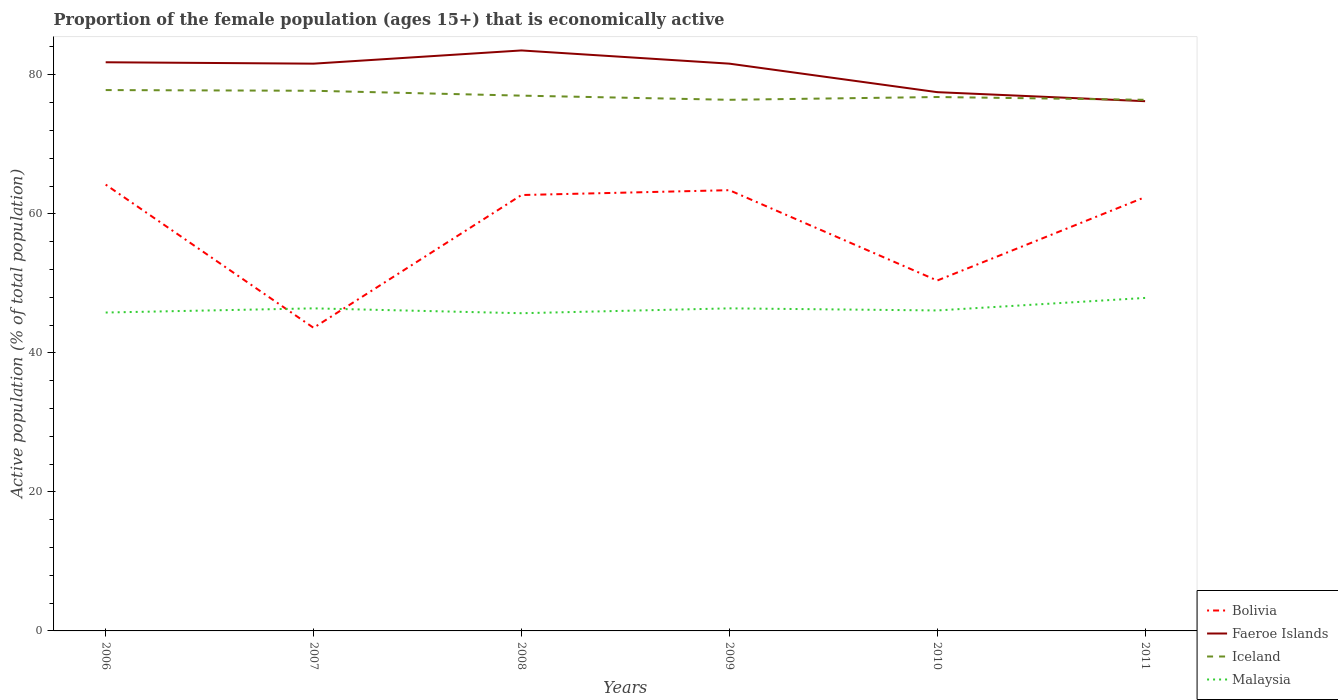How many different coloured lines are there?
Offer a very short reply. 4. Is the number of lines equal to the number of legend labels?
Offer a terse response. Yes. Across all years, what is the maximum proportion of the female population that is economically active in Iceland?
Offer a terse response. 76.4. What is the difference between the highest and the second highest proportion of the female population that is economically active in Faeroe Islands?
Provide a succinct answer. 7.3. What is the difference between the highest and the lowest proportion of the female population that is economically active in Bolivia?
Keep it short and to the point. 4. Is the proportion of the female population that is economically active in Faeroe Islands strictly greater than the proportion of the female population that is economically active in Bolivia over the years?
Your answer should be compact. No. How many lines are there?
Provide a succinct answer. 4. Where does the legend appear in the graph?
Offer a very short reply. Bottom right. How many legend labels are there?
Make the answer very short. 4. How are the legend labels stacked?
Your answer should be compact. Vertical. What is the title of the graph?
Give a very brief answer. Proportion of the female population (ages 15+) that is economically active. What is the label or title of the X-axis?
Offer a terse response. Years. What is the label or title of the Y-axis?
Offer a very short reply. Active population (% of total population). What is the Active population (% of total population) of Bolivia in 2006?
Offer a terse response. 64.2. What is the Active population (% of total population) in Faeroe Islands in 2006?
Your response must be concise. 81.8. What is the Active population (% of total population) of Iceland in 2006?
Provide a succinct answer. 77.8. What is the Active population (% of total population) in Malaysia in 2006?
Ensure brevity in your answer.  45.8. What is the Active population (% of total population) in Bolivia in 2007?
Ensure brevity in your answer.  43.6. What is the Active population (% of total population) of Faeroe Islands in 2007?
Offer a terse response. 81.6. What is the Active population (% of total population) in Iceland in 2007?
Your answer should be very brief. 77.7. What is the Active population (% of total population) of Malaysia in 2007?
Ensure brevity in your answer.  46.4. What is the Active population (% of total population) in Bolivia in 2008?
Provide a succinct answer. 62.7. What is the Active population (% of total population) in Faeroe Islands in 2008?
Make the answer very short. 83.5. What is the Active population (% of total population) in Iceland in 2008?
Ensure brevity in your answer.  77. What is the Active population (% of total population) in Malaysia in 2008?
Provide a short and direct response. 45.7. What is the Active population (% of total population) in Bolivia in 2009?
Your answer should be compact. 63.4. What is the Active population (% of total population) in Faeroe Islands in 2009?
Offer a very short reply. 81.6. What is the Active population (% of total population) in Iceland in 2009?
Your response must be concise. 76.4. What is the Active population (% of total population) in Malaysia in 2009?
Your answer should be very brief. 46.4. What is the Active population (% of total population) in Bolivia in 2010?
Offer a very short reply. 50.4. What is the Active population (% of total population) in Faeroe Islands in 2010?
Your answer should be very brief. 77.5. What is the Active population (% of total population) of Iceland in 2010?
Your answer should be very brief. 76.8. What is the Active population (% of total population) of Malaysia in 2010?
Your answer should be very brief. 46.1. What is the Active population (% of total population) in Bolivia in 2011?
Provide a short and direct response. 62.4. What is the Active population (% of total population) in Faeroe Islands in 2011?
Keep it short and to the point. 76.2. What is the Active population (% of total population) in Iceland in 2011?
Keep it short and to the point. 76.4. What is the Active population (% of total population) in Malaysia in 2011?
Provide a short and direct response. 47.9. Across all years, what is the maximum Active population (% of total population) in Bolivia?
Offer a very short reply. 64.2. Across all years, what is the maximum Active population (% of total population) of Faeroe Islands?
Offer a very short reply. 83.5. Across all years, what is the maximum Active population (% of total population) in Iceland?
Your answer should be very brief. 77.8. Across all years, what is the maximum Active population (% of total population) in Malaysia?
Offer a terse response. 47.9. Across all years, what is the minimum Active population (% of total population) in Bolivia?
Make the answer very short. 43.6. Across all years, what is the minimum Active population (% of total population) in Faeroe Islands?
Ensure brevity in your answer.  76.2. Across all years, what is the minimum Active population (% of total population) in Iceland?
Offer a very short reply. 76.4. Across all years, what is the minimum Active population (% of total population) in Malaysia?
Provide a succinct answer. 45.7. What is the total Active population (% of total population) in Bolivia in the graph?
Provide a succinct answer. 346.7. What is the total Active population (% of total population) in Faeroe Islands in the graph?
Your answer should be compact. 482.2. What is the total Active population (% of total population) of Iceland in the graph?
Offer a terse response. 462.1. What is the total Active population (% of total population) of Malaysia in the graph?
Your response must be concise. 278.3. What is the difference between the Active population (% of total population) of Bolivia in 2006 and that in 2007?
Offer a very short reply. 20.6. What is the difference between the Active population (% of total population) of Iceland in 2006 and that in 2007?
Offer a very short reply. 0.1. What is the difference between the Active population (% of total population) of Iceland in 2006 and that in 2008?
Offer a terse response. 0.8. What is the difference between the Active population (% of total population) in Malaysia in 2006 and that in 2008?
Your response must be concise. 0.1. What is the difference between the Active population (% of total population) of Faeroe Islands in 2006 and that in 2009?
Offer a very short reply. 0.2. What is the difference between the Active population (% of total population) in Iceland in 2006 and that in 2009?
Your response must be concise. 1.4. What is the difference between the Active population (% of total population) in Bolivia in 2006 and that in 2010?
Provide a succinct answer. 13.8. What is the difference between the Active population (% of total population) of Faeroe Islands in 2006 and that in 2010?
Make the answer very short. 4.3. What is the difference between the Active population (% of total population) in Bolivia in 2006 and that in 2011?
Your answer should be compact. 1.8. What is the difference between the Active population (% of total population) of Bolivia in 2007 and that in 2008?
Your answer should be compact. -19.1. What is the difference between the Active population (% of total population) in Malaysia in 2007 and that in 2008?
Give a very brief answer. 0.7. What is the difference between the Active population (% of total population) of Bolivia in 2007 and that in 2009?
Offer a terse response. -19.8. What is the difference between the Active population (% of total population) of Bolivia in 2007 and that in 2010?
Make the answer very short. -6.8. What is the difference between the Active population (% of total population) of Iceland in 2007 and that in 2010?
Your answer should be very brief. 0.9. What is the difference between the Active population (% of total population) of Bolivia in 2007 and that in 2011?
Your answer should be compact. -18.8. What is the difference between the Active population (% of total population) in Iceland in 2007 and that in 2011?
Offer a terse response. 1.3. What is the difference between the Active population (% of total population) in Malaysia in 2007 and that in 2011?
Offer a very short reply. -1.5. What is the difference between the Active population (% of total population) of Bolivia in 2008 and that in 2009?
Provide a succinct answer. -0.7. What is the difference between the Active population (% of total population) in Iceland in 2008 and that in 2009?
Offer a very short reply. 0.6. What is the difference between the Active population (% of total population) in Malaysia in 2008 and that in 2009?
Keep it short and to the point. -0.7. What is the difference between the Active population (% of total population) in Malaysia in 2008 and that in 2010?
Offer a very short reply. -0.4. What is the difference between the Active population (% of total population) of Bolivia in 2008 and that in 2011?
Provide a succinct answer. 0.3. What is the difference between the Active population (% of total population) of Faeroe Islands in 2008 and that in 2011?
Offer a terse response. 7.3. What is the difference between the Active population (% of total population) in Malaysia in 2008 and that in 2011?
Provide a short and direct response. -2.2. What is the difference between the Active population (% of total population) of Bolivia in 2009 and that in 2010?
Offer a very short reply. 13. What is the difference between the Active population (% of total population) of Faeroe Islands in 2009 and that in 2010?
Provide a short and direct response. 4.1. What is the difference between the Active population (% of total population) in Iceland in 2009 and that in 2010?
Ensure brevity in your answer.  -0.4. What is the difference between the Active population (% of total population) of Malaysia in 2009 and that in 2010?
Ensure brevity in your answer.  0.3. What is the difference between the Active population (% of total population) in Bolivia in 2009 and that in 2011?
Provide a succinct answer. 1. What is the difference between the Active population (% of total population) in Faeroe Islands in 2009 and that in 2011?
Your answer should be very brief. 5.4. What is the difference between the Active population (% of total population) in Iceland in 2009 and that in 2011?
Give a very brief answer. 0. What is the difference between the Active population (% of total population) of Malaysia in 2009 and that in 2011?
Provide a short and direct response. -1.5. What is the difference between the Active population (% of total population) of Bolivia in 2010 and that in 2011?
Your answer should be very brief. -12. What is the difference between the Active population (% of total population) in Bolivia in 2006 and the Active population (% of total population) in Faeroe Islands in 2007?
Your answer should be very brief. -17.4. What is the difference between the Active population (% of total population) of Bolivia in 2006 and the Active population (% of total population) of Malaysia in 2007?
Give a very brief answer. 17.8. What is the difference between the Active population (% of total population) of Faeroe Islands in 2006 and the Active population (% of total population) of Malaysia in 2007?
Make the answer very short. 35.4. What is the difference between the Active population (% of total population) in Iceland in 2006 and the Active population (% of total population) in Malaysia in 2007?
Your answer should be compact. 31.4. What is the difference between the Active population (% of total population) in Bolivia in 2006 and the Active population (% of total population) in Faeroe Islands in 2008?
Ensure brevity in your answer.  -19.3. What is the difference between the Active population (% of total population) in Bolivia in 2006 and the Active population (% of total population) in Iceland in 2008?
Offer a terse response. -12.8. What is the difference between the Active population (% of total population) in Faeroe Islands in 2006 and the Active population (% of total population) in Malaysia in 2008?
Offer a very short reply. 36.1. What is the difference between the Active population (% of total population) of Iceland in 2006 and the Active population (% of total population) of Malaysia in 2008?
Ensure brevity in your answer.  32.1. What is the difference between the Active population (% of total population) of Bolivia in 2006 and the Active population (% of total population) of Faeroe Islands in 2009?
Provide a short and direct response. -17.4. What is the difference between the Active population (% of total population) of Bolivia in 2006 and the Active population (% of total population) of Malaysia in 2009?
Your answer should be very brief. 17.8. What is the difference between the Active population (% of total population) in Faeroe Islands in 2006 and the Active population (% of total population) in Iceland in 2009?
Provide a succinct answer. 5.4. What is the difference between the Active population (% of total population) in Faeroe Islands in 2006 and the Active population (% of total population) in Malaysia in 2009?
Give a very brief answer. 35.4. What is the difference between the Active population (% of total population) in Iceland in 2006 and the Active population (% of total population) in Malaysia in 2009?
Provide a succinct answer. 31.4. What is the difference between the Active population (% of total population) in Bolivia in 2006 and the Active population (% of total population) in Malaysia in 2010?
Provide a succinct answer. 18.1. What is the difference between the Active population (% of total population) in Faeroe Islands in 2006 and the Active population (% of total population) in Iceland in 2010?
Your response must be concise. 5. What is the difference between the Active population (% of total population) in Faeroe Islands in 2006 and the Active population (% of total population) in Malaysia in 2010?
Your answer should be very brief. 35.7. What is the difference between the Active population (% of total population) of Iceland in 2006 and the Active population (% of total population) of Malaysia in 2010?
Give a very brief answer. 31.7. What is the difference between the Active population (% of total population) of Bolivia in 2006 and the Active population (% of total population) of Faeroe Islands in 2011?
Your answer should be compact. -12. What is the difference between the Active population (% of total population) of Bolivia in 2006 and the Active population (% of total population) of Iceland in 2011?
Offer a terse response. -12.2. What is the difference between the Active population (% of total population) of Faeroe Islands in 2006 and the Active population (% of total population) of Malaysia in 2011?
Provide a succinct answer. 33.9. What is the difference between the Active population (% of total population) of Iceland in 2006 and the Active population (% of total population) of Malaysia in 2011?
Provide a succinct answer. 29.9. What is the difference between the Active population (% of total population) of Bolivia in 2007 and the Active population (% of total population) of Faeroe Islands in 2008?
Offer a terse response. -39.9. What is the difference between the Active population (% of total population) of Bolivia in 2007 and the Active population (% of total population) of Iceland in 2008?
Your answer should be very brief. -33.4. What is the difference between the Active population (% of total population) of Bolivia in 2007 and the Active population (% of total population) of Malaysia in 2008?
Your answer should be very brief. -2.1. What is the difference between the Active population (% of total population) of Faeroe Islands in 2007 and the Active population (% of total population) of Iceland in 2008?
Provide a short and direct response. 4.6. What is the difference between the Active population (% of total population) in Faeroe Islands in 2007 and the Active population (% of total population) in Malaysia in 2008?
Keep it short and to the point. 35.9. What is the difference between the Active population (% of total population) in Bolivia in 2007 and the Active population (% of total population) in Faeroe Islands in 2009?
Provide a short and direct response. -38. What is the difference between the Active population (% of total population) of Bolivia in 2007 and the Active population (% of total population) of Iceland in 2009?
Make the answer very short. -32.8. What is the difference between the Active population (% of total population) of Faeroe Islands in 2007 and the Active population (% of total population) of Malaysia in 2009?
Give a very brief answer. 35.2. What is the difference between the Active population (% of total population) in Iceland in 2007 and the Active population (% of total population) in Malaysia in 2009?
Ensure brevity in your answer.  31.3. What is the difference between the Active population (% of total population) in Bolivia in 2007 and the Active population (% of total population) in Faeroe Islands in 2010?
Offer a very short reply. -33.9. What is the difference between the Active population (% of total population) of Bolivia in 2007 and the Active population (% of total population) of Iceland in 2010?
Give a very brief answer. -33.2. What is the difference between the Active population (% of total population) in Bolivia in 2007 and the Active population (% of total population) in Malaysia in 2010?
Offer a very short reply. -2.5. What is the difference between the Active population (% of total population) of Faeroe Islands in 2007 and the Active population (% of total population) of Malaysia in 2010?
Ensure brevity in your answer.  35.5. What is the difference between the Active population (% of total population) of Iceland in 2007 and the Active population (% of total population) of Malaysia in 2010?
Keep it short and to the point. 31.6. What is the difference between the Active population (% of total population) of Bolivia in 2007 and the Active population (% of total population) of Faeroe Islands in 2011?
Offer a very short reply. -32.6. What is the difference between the Active population (% of total population) in Bolivia in 2007 and the Active population (% of total population) in Iceland in 2011?
Provide a succinct answer. -32.8. What is the difference between the Active population (% of total population) of Bolivia in 2007 and the Active population (% of total population) of Malaysia in 2011?
Provide a succinct answer. -4.3. What is the difference between the Active population (% of total population) of Faeroe Islands in 2007 and the Active population (% of total population) of Iceland in 2011?
Your answer should be very brief. 5.2. What is the difference between the Active population (% of total population) of Faeroe Islands in 2007 and the Active population (% of total population) of Malaysia in 2011?
Your answer should be very brief. 33.7. What is the difference between the Active population (% of total population) of Iceland in 2007 and the Active population (% of total population) of Malaysia in 2011?
Offer a terse response. 29.8. What is the difference between the Active population (% of total population) in Bolivia in 2008 and the Active population (% of total population) in Faeroe Islands in 2009?
Your answer should be compact. -18.9. What is the difference between the Active population (% of total population) of Bolivia in 2008 and the Active population (% of total population) of Iceland in 2009?
Give a very brief answer. -13.7. What is the difference between the Active population (% of total population) of Bolivia in 2008 and the Active population (% of total population) of Malaysia in 2009?
Your response must be concise. 16.3. What is the difference between the Active population (% of total population) of Faeroe Islands in 2008 and the Active population (% of total population) of Iceland in 2009?
Give a very brief answer. 7.1. What is the difference between the Active population (% of total population) in Faeroe Islands in 2008 and the Active population (% of total population) in Malaysia in 2009?
Offer a very short reply. 37.1. What is the difference between the Active population (% of total population) in Iceland in 2008 and the Active population (% of total population) in Malaysia in 2009?
Provide a succinct answer. 30.6. What is the difference between the Active population (% of total population) of Bolivia in 2008 and the Active population (% of total population) of Faeroe Islands in 2010?
Give a very brief answer. -14.8. What is the difference between the Active population (% of total population) in Bolivia in 2008 and the Active population (% of total population) in Iceland in 2010?
Your response must be concise. -14.1. What is the difference between the Active population (% of total population) in Bolivia in 2008 and the Active population (% of total population) in Malaysia in 2010?
Offer a very short reply. 16.6. What is the difference between the Active population (% of total population) in Faeroe Islands in 2008 and the Active population (% of total population) in Iceland in 2010?
Give a very brief answer. 6.7. What is the difference between the Active population (% of total population) in Faeroe Islands in 2008 and the Active population (% of total population) in Malaysia in 2010?
Keep it short and to the point. 37.4. What is the difference between the Active population (% of total population) of Iceland in 2008 and the Active population (% of total population) of Malaysia in 2010?
Your answer should be compact. 30.9. What is the difference between the Active population (% of total population) of Bolivia in 2008 and the Active population (% of total population) of Faeroe Islands in 2011?
Make the answer very short. -13.5. What is the difference between the Active population (% of total population) of Bolivia in 2008 and the Active population (% of total population) of Iceland in 2011?
Provide a short and direct response. -13.7. What is the difference between the Active population (% of total population) in Bolivia in 2008 and the Active population (% of total population) in Malaysia in 2011?
Give a very brief answer. 14.8. What is the difference between the Active population (% of total population) in Faeroe Islands in 2008 and the Active population (% of total population) in Iceland in 2011?
Provide a short and direct response. 7.1. What is the difference between the Active population (% of total population) of Faeroe Islands in 2008 and the Active population (% of total population) of Malaysia in 2011?
Provide a short and direct response. 35.6. What is the difference between the Active population (% of total population) of Iceland in 2008 and the Active population (% of total population) of Malaysia in 2011?
Your answer should be compact. 29.1. What is the difference between the Active population (% of total population) of Bolivia in 2009 and the Active population (% of total population) of Faeroe Islands in 2010?
Keep it short and to the point. -14.1. What is the difference between the Active population (% of total population) in Bolivia in 2009 and the Active population (% of total population) in Iceland in 2010?
Your answer should be very brief. -13.4. What is the difference between the Active population (% of total population) of Faeroe Islands in 2009 and the Active population (% of total population) of Iceland in 2010?
Your answer should be very brief. 4.8. What is the difference between the Active population (% of total population) of Faeroe Islands in 2009 and the Active population (% of total population) of Malaysia in 2010?
Offer a terse response. 35.5. What is the difference between the Active population (% of total population) of Iceland in 2009 and the Active population (% of total population) of Malaysia in 2010?
Offer a terse response. 30.3. What is the difference between the Active population (% of total population) of Bolivia in 2009 and the Active population (% of total population) of Malaysia in 2011?
Your response must be concise. 15.5. What is the difference between the Active population (% of total population) of Faeroe Islands in 2009 and the Active population (% of total population) of Malaysia in 2011?
Offer a terse response. 33.7. What is the difference between the Active population (% of total population) in Bolivia in 2010 and the Active population (% of total population) in Faeroe Islands in 2011?
Offer a terse response. -25.8. What is the difference between the Active population (% of total population) of Bolivia in 2010 and the Active population (% of total population) of Malaysia in 2011?
Your answer should be very brief. 2.5. What is the difference between the Active population (% of total population) in Faeroe Islands in 2010 and the Active population (% of total population) in Malaysia in 2011?
Give a very brief answer. 29.6. What is the difference between the Active population (% of total population) of Iceland in 2010 and the Active population (% of total population) of Malaysia in 2011?
Provide a succinct answer. 28.9. What is the average Active population (% of total population) of Bolivia per year?
Make the answer very short. 57.78. What is the average Active population (% of total population) of Faeroe Islands per year?
Give a very brief answer. 80.37. What is the average Active population (% of total population) in Iceland per year?
Your answer should be compact. 77.02. What is the average Active population (% of total population) of Malaysia per year?
Offer a terse response. 46.38. In the year 2006, what is the difference between the Active population (% of total population) of Bolivia and Active population (% of total population) of Faeroe Islands?
Your answer should be very brief. -17.6. In the year 2006, what is the difference between the Active population (% of total population) of Bolivia and Active population (% of total population) of Iceland?
Your answer should be very brief. -13.6. In the year 2006, what is the difference between the Active population (% of total population) in Bolivia and Active population (% of total population) in Malaysia?
Give a very brief answer. 18.4. In the year 2007, what is the difference between the Active population (% of total population) of Bolivia and Active population (% of total population) of Faeroe Islands?
Ensure brevity in your answer.  -38. In the year 2007, what is the difference between the Active population (% of total population) of Bolivia and Active population (% of total population) of Iceland?
Offer a terse response. -34.1. In the year 2007, what is the difference between the Active population (% of total population) of Bolivia and Active population (% of total population) of Malaysia?
Your answer should be compact. -2.8. In the year 2007, what is the difference between the Active population (% of total population) in Faeroe Islands and Active population (% of total population) in Malaysia?
Your answer should be compact. 35.2. In the year 2007, what is the difference between the Active population (% of total population) of Iceland and Active population (% of total population) of Malaysia?
Offer a terse response. 31.3. In the year 2008, what is the difference between the Active population (% of total population) of Bolivia and Active population (% of total population) of Faeroe Islands?
Offer a terse response. -20.8. In the year 2008, what is the difference between the Active population (% of total population) in Bolivia and Active population (% of total population) in Iceland?
Your answer should be compact. -14.3. In the year 2008, what is the difference between the Active population (% of total population) in Faeroe Islands and Active population (% of total population) in Malaysia?
Your answer should be very brief. 37.8. In the year 2008, what is the difference between the Active population (% of total population) of Iceland and Active population (% of total population) of Malaysia?
Your answer should be very brief. 31.3. In the year 2009, what is the difference between the Active population (% of total population) in Bolivia and Active population (% of total population) in Faeroe Islands?
Your answer should be compact. -18.2. In the year 2009, what is the difference between the Active population (% of total population) in Faeroe Islands and Active population (% of total population) in Malaysia?
Your answer should be compact. 35.2. In the year 2010, what is the difference between the Active population (% of total population) of Bolivia and Active population (% of total population) of Faeroe Islands?
Keep it short and to the point. -27.1. In the year 2010, what is the difference between the Active population (% of total population) in Bolivia and Active population (% of total population) in Iceland?
Ensure brevity in your answer.  -26.4. In the year 2010, what is the difference between the Active population (% of total population) in Bolivia and Active population (% of total population) in Malaysia?
Offer a terse response. 4.3. In the year 2010, what is the difference between the Active population (% of total population) in Faeroe Islands and Active population (% of total population) in Iceland?
Your answer should be compact. 0.7. In the year 2010, what is the difference between the Active population (% of total population) in Faeroe Islands and Active population (% of total population) in Malaysia?
Offer a terse response. 31.4. In the year 2010, what is the difference between the Active population (% of total population) in Iceland and Active population (% of total population) in Malaysia?
Make the answer very short. 30.7. In the year 2011, what is the difference between the Active population (% of total population) of Bolivia and Active population (% of total population) of Faeroe Islands?
Provide a succinct answer. -13.8. In the year 2011, what is the difference between the Active population (% of total population) in Bolivia and Active population (% of total population) in Malaysia?
Keep it short and to the point. 14.5. In the year 2011, what is the difference between the Active population (% of total population) of Faeroe Islands and Active population (% of total population) of Iceland?
Give a very brief answer. -0.2. In the year 2011, what is the difference between the Active population (% of total population) in Faeroe Islands and Active population (% of total population) in Malaysia?
Ensure brevity in your answer.  28.3. What is the ratio of the Active population (% of total population) in Bolivia in 2006 to that in 2007?
Ensure brevity in your answer.  1.47. What is the ratio of the Active population (% of total population) in Faeroe Islands in 2006 to that in 2007?
Your answer should be compact. 1. What is the ratio of the Active population (% of total population) in Iceland in 2006 to that in 2007?
Your answer should be very brief. 1. What is the ratio of the Active population (% of total population) of Malaysia in 2006 to that in 2007?
Ensure brevity in your answer.  0.99. What is the ratio of the Active population (% of total population) in Bolivia in 2006 to that in 2008?
Provide a short and direct response. 1.02. What is the ratio of the Active population (% of total population) in Faeroe Islands in 2006 to that in 2008?
Ensure brevity in your answer.  0.98. What is the ratio of the Active population (% of total population) in Iceland in 2006 to that in 2008?
Give a very brief answer. 1.01. What is the ratio of the Active population (% of total population) in Bolivia in 2006 to that in 2009?
Provide a short and direct response. 1.01. What is the ratio of the Active population (% of total population) in Faeroe Islands in 2006 to that in 2009?
Make the answer very short. 1. What is the ratio of the Active population (% of total population) of Iceland in 2006 to that in 2009?
Offer a terse response. 1.02. What is the ratio of the Active population (% of total population) of Malaysia in 2006 to that in 2009?
Offer a terse response. 0.99. What is the ratio of the Active population (% of total population) of Bolivia in 2006 to that in 2010?
Provide a succinct answer. 1.27. What is the ratio of the Active population (% of total population) of Faeroe Islands in 2006 to that in 2010?
Your response must be concise. 1.06. What is the ratio of the Active population (% of total population) of Malaysia in 2006 to that in 2010?
Provide a short and direct response. 0.99. What is the ratio of the Active population (% of total population) in Bolivia in 2006 to that in 2011?
Your response must be concise. 1.03. What is the ratio of the Active population (% of total population) in Faeroe Islands in 2006 to that in 2011?
Ensure brevity in your answer.  1.07. What is the ratio of the Active population (% of total population) in Iceland in 2006 to that in 2011?
Your answer should be compact. 1.02. What is the ratio of the Active population (% of total population) in Malaysia in 2006 to that in 2011?
Your answer should be compact. 0.96. What is the ratio of the Active population (% of total population) in Bolivia in 2007 to that in 2008?
Your answer should be compact. 0.7. What is the ratio of the Active population (% of total population) in Faeroe Islands in 2007 to that in 2008?
Keep it short and to the point. 0.98. What is the ratio of the Active population (% of total population) of Iceland in 2007 to that in 2008?
Offer a very short reply. 1.01. What is the ratio of the Active population (% of total population) in Malaysia in 2007 to that in 2008?
Provide a succinct answer. 1.02. What is the ratio of the Active population (% of total population) of Bolivia in 2007 to that in 2009?
Make the answer very short. 0.69. What is the ratio of the Active population (% of total population) of Bolivia in 2007 to that in 2010?
Offer a very short reply. 0.87. What is the ratio of the Active population (% of total population) of Faeroe Islands in 2007 to that in 2010?
Offer a terse response. 1.05. What is the ratio of the Active population (% of total population) in Iceland in 2007 to that in 2010?
Provide a short and direct response. 1.01. What is the ratio of the Active population (% of total population) in Bolivia in 2007 to that in 2011?
Your answer should be compact. 0.7. What is the ratio of the Active population (% of total population) of Faeroe Islands in 2007 to that in 2011?
Provide a short and direct response. 1.07. What is the ratio of the Active population (% of total population) of Malaysia in 2007 to that in 2011?
Your answer should be compact. 0.97. What is the ratio of the Active population (% of total population) in Faeroe Islands in 2008 to that in 2009?
Offer a very short reply. 1.02. What is the ratio of the Active population (% of total population) of Iceland in 2008 to that in 2009?
Make the answer very short. 1.01. What is the ratio of the Active population (% of total population) in Malaysia in 2008 to that in 2009?
Your answer should be compact. 0.98. What is the ratio of the Active population (% of total population) of Bolivia in 2008 to that in 2010?
Your response must be concise. 1.24. What is the ratio of the Active population (% of total population) in Faeroe Islands in 2008 to that in 2010?
Your answer should be very brief. 1.08. What is the ratio of the Active population (% of total population) of Iceland in 2008 to that in 2010?
Make the answer very short. 1. What is the ratio of the Active population (% of total population) of Faeroe Islands in 2008 to that in 2011?
Your answer should be very brief. 1.1. What is the ratio of the Active population (% of total population) of Iceland in 2008 to that in 2011?
Provide a succinct answer. 1.01. What is the ratio of the Active population (% of total population) in Malaysia in 2008 to that in 2011?
Ensure brevity in your answer.  0.95. What is the ratio of the Active population (% of total population) in Bolivia in 2009 to that in 2010?
Offer a very short reply. 1.26. What is the ratio of the Active population (% of total population) of Faeroe Islands in 2009 to that in 2010?
Give a very brief answer. 1.05. What is the ratio of the Active population (% of total population) of Malaysia in 2009 to that in 2010?
Your response must be concise. 1.01. What is the ratio of the Active population (% of total population) in Bolivia in 2009 to that in 2011?
Your response must be concise. 1.02. What is the ratio of the Active population (% of total population) of Faeroe Islands in 2009 to that in 2011?
Give a very brief answer. 1.07. What is the ratio of the Active population (% of total population) in Iceland in 2009 to that in 2011?
Your answer should be very brief. 1. What is the ratio of the Active population (% of total population) in Malaysia in 2009 to that in 2011?
Your answer should be compact. 0.97. What is the ratio of the Active population (% of total population) in Bolivia in 2010 to that in 2011?
Offer a terse response. 0.81. What is the ratio of the Active population (% of total population) in Faeroe Islands in 2010 to that in 2011?
Make the answer very short. 1.02. What is the ratio of the Active population (% of total population) in Iceland in 2010 to that in 2011?
Ensure brevity in your answer.  1.01. What is the ratio of the Active population (% of total population) of Malaysia in 2010 to that in 2011?
Keep it short and to the point. 0.96. What is the difference between the highest and the second highest Active population (% of total population) in Iceland?
Keep it short and to the point. 0.1. What is the difference between the highest and the lowest Active population (% of total population) of Bolivia?
Your answer should be very brief. 20.6. What is the difference between the highest and the lowest Active population (% of total population) in Iceland?
Keep it short and to the point. 1.4. 